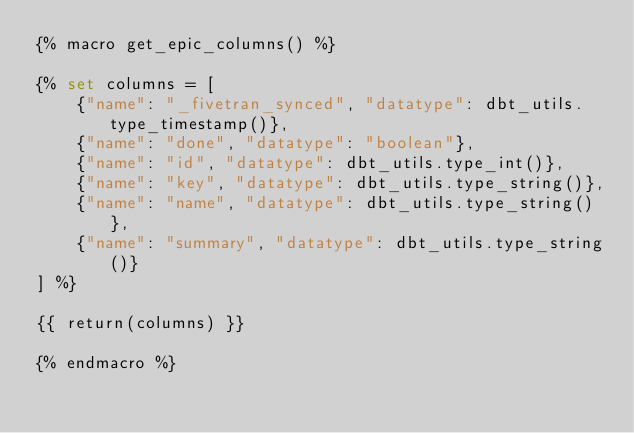<code> <loc_0><loc_0><loc_500><loc_500><_SQL_>{% macro get_epic_columns() %}

{% set columns = [
    {"name": "_fivetran_synced", "datatype": dbt_utils.type_timestamp()},
    {"name": "done", "datatype": "boolean"},
    {"name": "id", "datatype": dbt_utils.type_int()},
    {"name": "key", "datatype": dbt_utils.type_string()},
    {"name": "name", "datatype": dbt_utils.type_string()},
    {"name": "summary", "datatype": dbt_utils.type_string()}
] %}

{{ return(columns) }}

{% endmacro %}</code> 